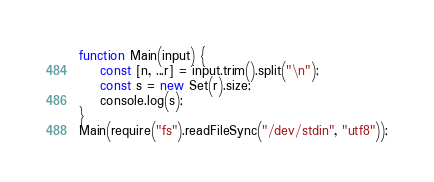Convert code to text. <code><loc_0><loc_0><loc_500><loc_500><_TypeScript_>function Main(input) {
	const [n, ...r] = input.trim().split("\n");
    const s = new Set(r).size;
    console.log(s);
}
Main(require("fs").readFileSync("/dev/stdin", "utf8"));</code> 